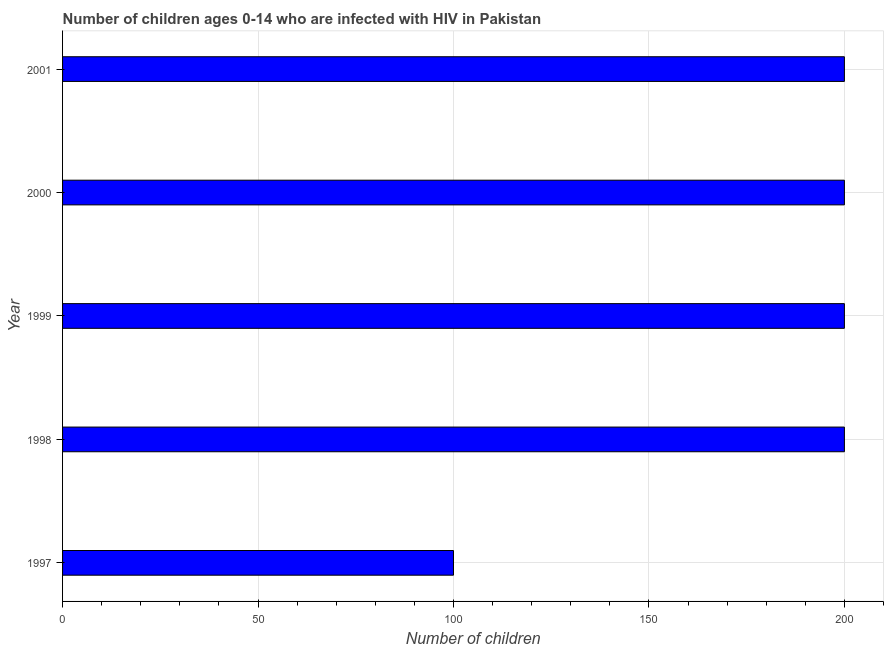Does the graph contain any zero values?
Your response must be concise. No. What is the title of the graph?
Offer a terse response. Number of children ages 0-14 who are infected with HIV in Pakistan. What is the label or title of the X-axis?
Make the answer very short. Number of children. Across all years, what is the maximum number of children living with hiv?
Your answer should be very brief. 200. In which year was the number of children living with hiv minimum?
Provide a short and direct response. 1997. What is the sum of the number of children living with hiv?
Your answer should be compact. 900. What is the average number of children living with hiv per year?
Give a very brief answer. 180. What is the ratio of the number of children living with hiv in 1997 to that in 1999?
Your answer should be compact. 0.5. Is the difference between the number of children living with hiv in 1997 and 2001 greater than the difference between any two years?
Offer a terse response. Yes. What is the difference between the highest and the second highest number of children living with hiv?
Provide a succinct answer. 0. What is the difference between the highest and the lowest number of children living with hiv?
Provide a short and direct response. 100. Are all the bars in the graph horizontal?
Keep it short and to the point. Yes. How many years are there in the graph?
Make the answer very short. 5. What is the Number of children of 1997?
Ensure brevity in your answer.  100. What is the Number of children in 1998?
Keep it short and to the point. 200. What is the Number of children of 1999?
Your response must be concise. 200. What is the Number of children of 2000?
Your answer should be compact. 200. What is the Number of children of 2001?
Ensure brevity in your answer.  200. What is the difference between the Number of children in 1997 and 1998?
Your answer should be very brief. -100. What is the difference between the Number of children in 1997 and 1999?
Provide a succinct answer. -100. What is the difference between the Number of children in 1997 and 2000?
Ensure brevity in your answer.  -100. What is the difference between the Number of children in 1997 and 2001?
Make the answer very short. -100. What is the difference between the Number of children in 1998 and 1999?
Ensure brevity in your answer.  0. What is the difference between the Number of children in 1998 and 2000?
Give a very brief answer. 0. What is the difference between the Number of children in 1998 and 2001?
Provide a succinct answer. 0. What is the difference between the Number of children in 1999 and 2000?
Your answer should be very brief. 0. What is the ratio of the Number of children in 1997 to that in 1998?
Give a very brief answer. 0.5. What is the ratio of the Number of children in 1997 to that in 2000?
Provide a succinct answer. 0.5. What is the ratio of the Number of children in 1997 to that in 2001?
Your answer should be compact. 0.5. What is the ratio of the Number of children in 1998 to that in 1999?
Your response must be concise. 1. What is the ratio of the Number of children in 1999 to that in 2001?
Ensure brevity in your answer.  1. What is the ratio of the Number of children in 2000 to that in 2001?
Provide a succinct answer. 1. 